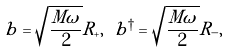Convert formula to latex. <formula><loc_0><loc_0><loc_500><loc_500>b = \sqrt { \frac { M \omega } { 2 } } R _ { + } , \ b ^ { \dagger } = \sqrt { \frac { M \omega } { 2 } } R _ { - } ,</formula> 